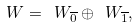<formula> <loc_0><loc_0><loc_500><loc_500>\ W = \ W _ { \overline { 0 } } \oplus \ W _ { \overline { 1 } } ,</formula> 